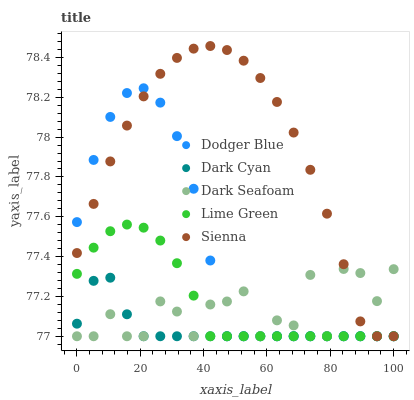Does Dark Cyan have the minimum area under the curve?
Answer yes or no. Yes. Does Sienna have the maximum area under the curve?
Answer yes or no. Yes. Does Lime Green have the minimum area under the curve?
Answer yes or no. No. Does Lime Green have the maximum area under the curve?
Answer yes or no. No. Is Lime Green the smoothest?
Answer yes or no. Yes. Is Dark Seafoam the roughest?
Answer yes or no. Yes. Is Dark Seafoam the smoothest?
Answer yes or no. No. Is Lime Green the roughest?
Answer yes or no. No. Does Dark Cyan have the lowest value?
Answer yes or no. Yes. Does Sienna have the highest value?
Answer yes or no. Yes. Does Lime Green have the highest value?
Answer yes or no. No. Does Dark Cyan intersect Dark Seafoam?
Answer yes or no. Yes. Is Dark Cyan less than Dark Seafoam?
Answer yes or no. No. Is Dark Cyan greater than Dark Seafoam?
Answer yes or no. No. 